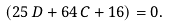Convert formula to latex. <formula><loc_0><loc_0><loc_500><loc_500>\left ( 2 5 \, D + 6 4 \, C + 1 6 \right ) = 0 .</formula> 